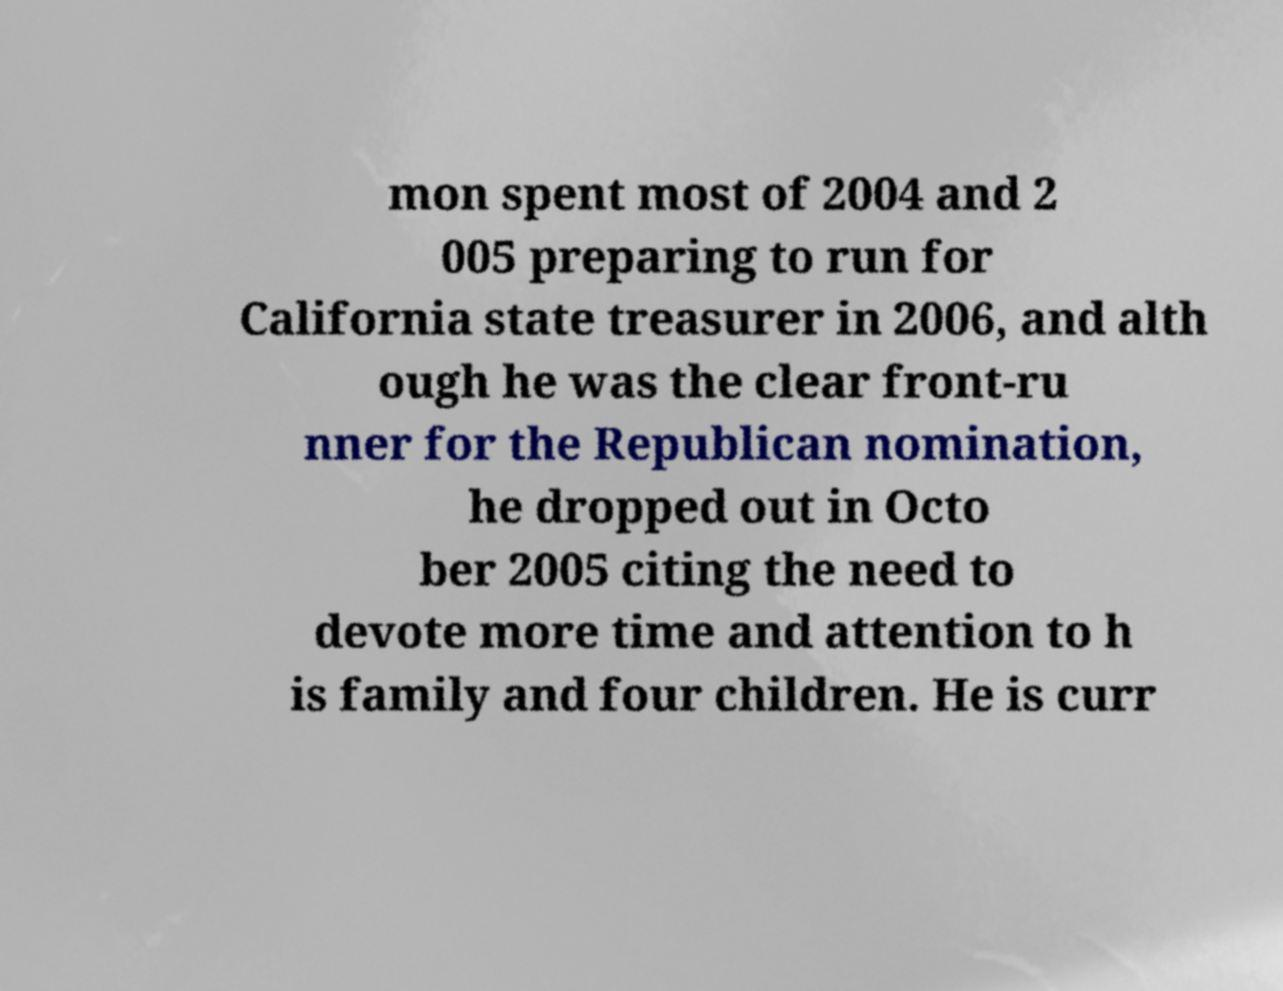Could you assist in decoding the text presented in this image and type it out clearly? mon spent most of 2004 and 2 005 preparing to run for California state treasurer in 2006, and alth ough he was the clear front-ru nner for the Republican nomination, he dropped out in Octo ber 2005 citing the need to devote more time and attention to h is family and four children. He is curr 